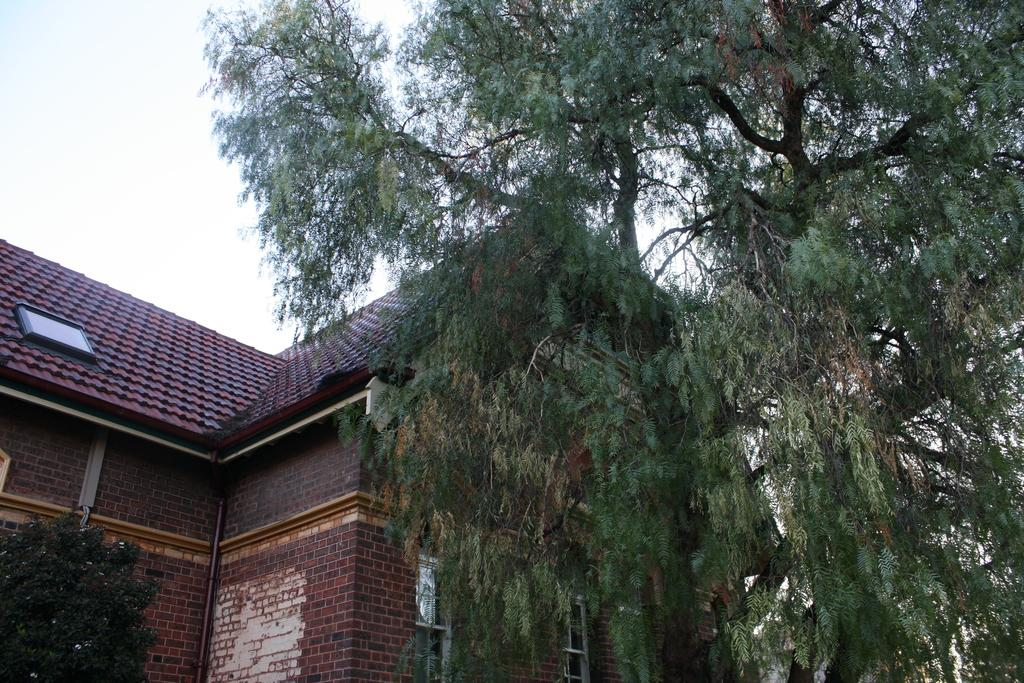What type of vegetation can be seen in the image? There are trees in the image. What type of structure is present in the image? There is a building with windows in the image. What object can be seen in the image that is used for transporting fluids? There is a pipe in the image. What is visible in the background of the image? The sky is visible in the background of the image. What word is being spoken by the trees in the image? There are no words spoken by the trees in the image, as trees do not have the ability to speak. 